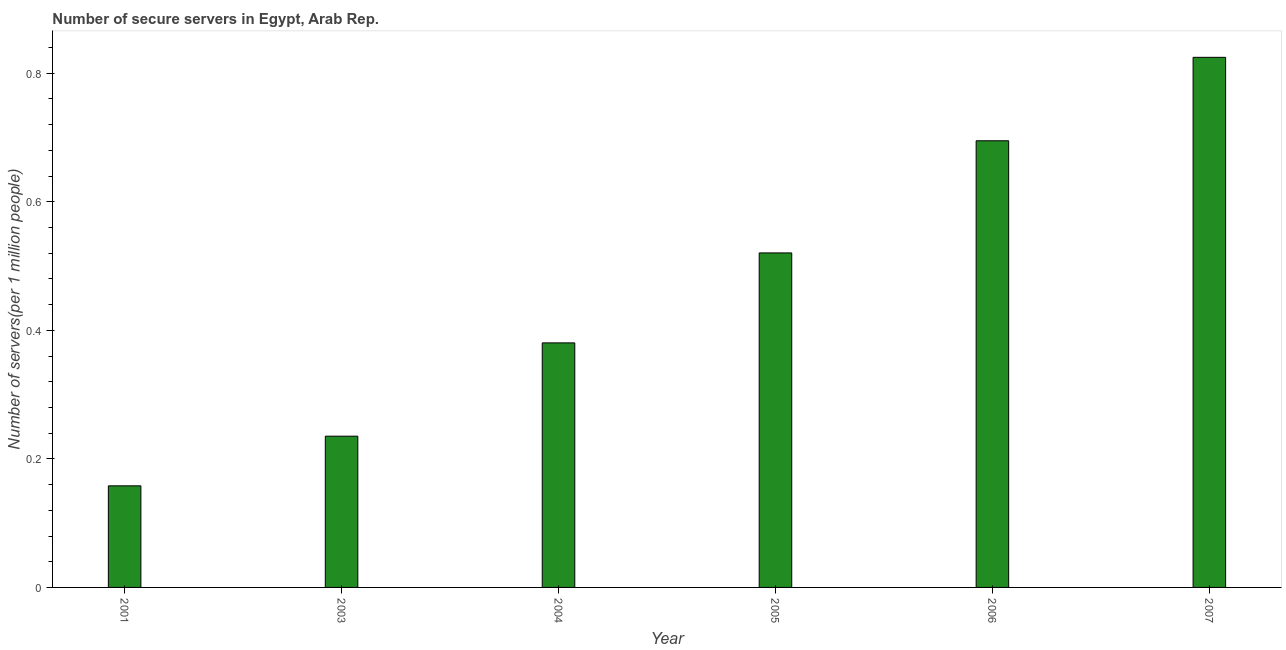Does the graph contain any zero values?
Ensure brevity in your answer.  No. Does the graph contain grids?
Offer a very short reply. No. What is the title of the graph?
Keep it short and to the point. Number of secure servers in Egypt, Arab Rep. What is the label or title of the Y-axis?
Keep it short and to the point. Number of servers(per 1 million people). What is the number of secure internet servers in 2005?
Keep it short and to the point. 0.52. Across all years, what is the maximum number of secure internet servers?
Your answer should be very brief. 0.82. Across all years, what is the minimum number of secure internet servers?
Keep it short and to the point. 0.16. What is the sum of the number of secure internet servers?
Your answer should be very brief. 2.81. What is the difference between the number of secure internet servers in 2005 and 2006?
Provide a short and direct response. -0.17. What is the average number of secure internet servers per year?
Provide a succinct answer. 0.47. What is the median number of secure internet servers?
Give a very brief answer. 0.45. In how many years, is the number of secure internet servers greater than 0.2 ?
Make the answer very short. 5. Do a majority of the years between 2006 and 2007 (inclusive) have number of secure internet servers greater than 0.4 ?
Your answer should be very brief. Yes. What is the ratio of the number of secure internet servers in 2001 to that in 2004?
Give a very brief answer. 0.41. Is the number of secure internet servers in 2003 less than that in 2007?
Make the answer very short. Yes. Is the difference between the number of secure internet servers in 2003 and 2004 greater than the difference between any two years?
Provide a short and direct response. No. What is the difference between the highest and the second highest number of secure internet servers?
Your response must be concise. 0.13. What is the difference between the highest and the lowest number of secure internet servers?
Keep it short and to the point. 0.67. In how many years, is the number of secure internet servers greater than the average number of secure internet servers taken over all years?
Your answer should be very brief. 3. How many bars are there?
Your response must be concise. 6. How many years are there in the graph?
Offer a terse response. 6. Are the values on the major ticks of Y-axis written in scientific E-notation?
Provide a succinct answer. No. What is the Number of servers(per 1 million people) in 2001?
Your answer should be compact. 0.16. What is the Number of servers(per 1 million people) of 2003?
Give a very brief answer. 0.24. What is the Number of servers(per 1 million people) in 2004?
Provide a succinct answer. 0.38. What is the Number of servers(per 1 million people) of 2005?
Offer a very short reply. 0.52. What is the Number of servers(per 1 million people) in 2006?
Provide a succinct answer. 0.69. What is the Number of servers(per 1 million people) of 2007?
Keep it short and to the point. 0.82. What is the difference between the Number of servers(per 1 million people) in 2001 and 2003?
Give a very brief answer. -0.08. What is the difference between the Number of servers(per 1 million people) in 2001 and 2004?
Ensure brevity in your answer.  -0.22. What is the difference between the Number of servers(per 1 million people) in 2001 and 2005?
Your answer should be very brief. -0.36. What is the difference between the Number of servers(per 1 million people) in 2001 and 2006?
Your answer should be compact. -0.54. What is the difference between the Number of servers(per 1 million people) in 2001 and 2007?
Give a very brief answer. -0.67. What is the difference between the Number of servers(per 1 million people) in 2003 and 2004?
Offer a terse response. -0.15. What is the difference between the Number of servers(per 1 million people) in 2003 and 2005?
Ensure brevity in your answer.  -0.29. What is the difference between the Number of servers(per 1 million people) in 2003 and 2006?
Make the answer very short. -0.46. What is the difference between the Number of servers(per 1 million people) in 2003 and 2007?
Your answer should be very brief. -0.59. What is the difference between the Number of servers(per 1 million people) in 2004 and 2005?
Offer a terse response. -0.14. What is the difference between the Number of servers(per 1 million people) in 2004 and 2006?
Make the answer very short. -0.31. What is the difference between the Number of servers(per 1 million people) in 2004 and 2007?
Ensure brevity in your answer.  -0.44. What is the difference between the Number of servers(per 1 million people) in 2005 and 2006?
Offer a terse response. -0.17. What is the difference between the Number of servers(per 1 million people) in 2005 and 2007?
Provide a short and direct response. -0.3. What is the difference between the Number of servers(per 1 million people) in 2006 and 2007?
Ensure brevity in your answer.  -0.13. What is the ratio of the Number of servers(per 1 million people) in 2001 to that in 2003?
Ensure brevity in your answer.  0.67. What is the ratio of the Number of servers(per 1 million people) in 2001 to that in 2004?
Your response must be concise. 0.41. What is the ratio of the Number of servers(per 1 million people) in 2001 to that in 2005?
Ensure brevity in your answer.  0.3. What is the ratio of the Number of servers(per 1 million people) in 2001 to that in 2006?
Your answer should be very brief. 0.23. What is the ratio of the Number of servers(per 1 million people) in 2001 to that in 2007?
Give a very brief answer. 0.19. What is the ratio of the Number of servers(per 1 million people) in 2003 to that in 2004?
Ensure brevity in your answer.  0.62. What is the ratio of the Number of servers(per 1 million people) in 2003 to that in 2005?
Ensure brevity in your answer.  0.45. What is the ratio of the Number of servers(per 1 million people) in 2003 to that in 2006?
Offer a very short reply. 0.34. What is the ratio of the Number of servers(per 1 million people) in 2003 to that in 2007?
Give a very brief answer. 0.28. What is the ratio of the Number of servers(per 1 million people) in 2004 to that in 2005?
Provide a short and direct response. 0.73. What is the ratio of the Number of servers(per 1 million people) in 2004 to that in 2006?
Ensure brevity in your answer.  0.55. What is the ratio of the Number of servers(per 1 million people) in 2004 to that in 2007?
Your answer should be very brief. 0.46. What is the ratio of the Number of servers(per 1 million people) in 2005 to that in 2006?
Your answer should be very brief. 0.75. What is the ratio of the Number of servers(per 1 million people) in 2005 to that in 2007?
Provide a succinct answer. 0.63. What is the ratio of the Number of servers(per 1 million people) in 2006 to that in 2007?
Your answer should be very brief. 0.84. 